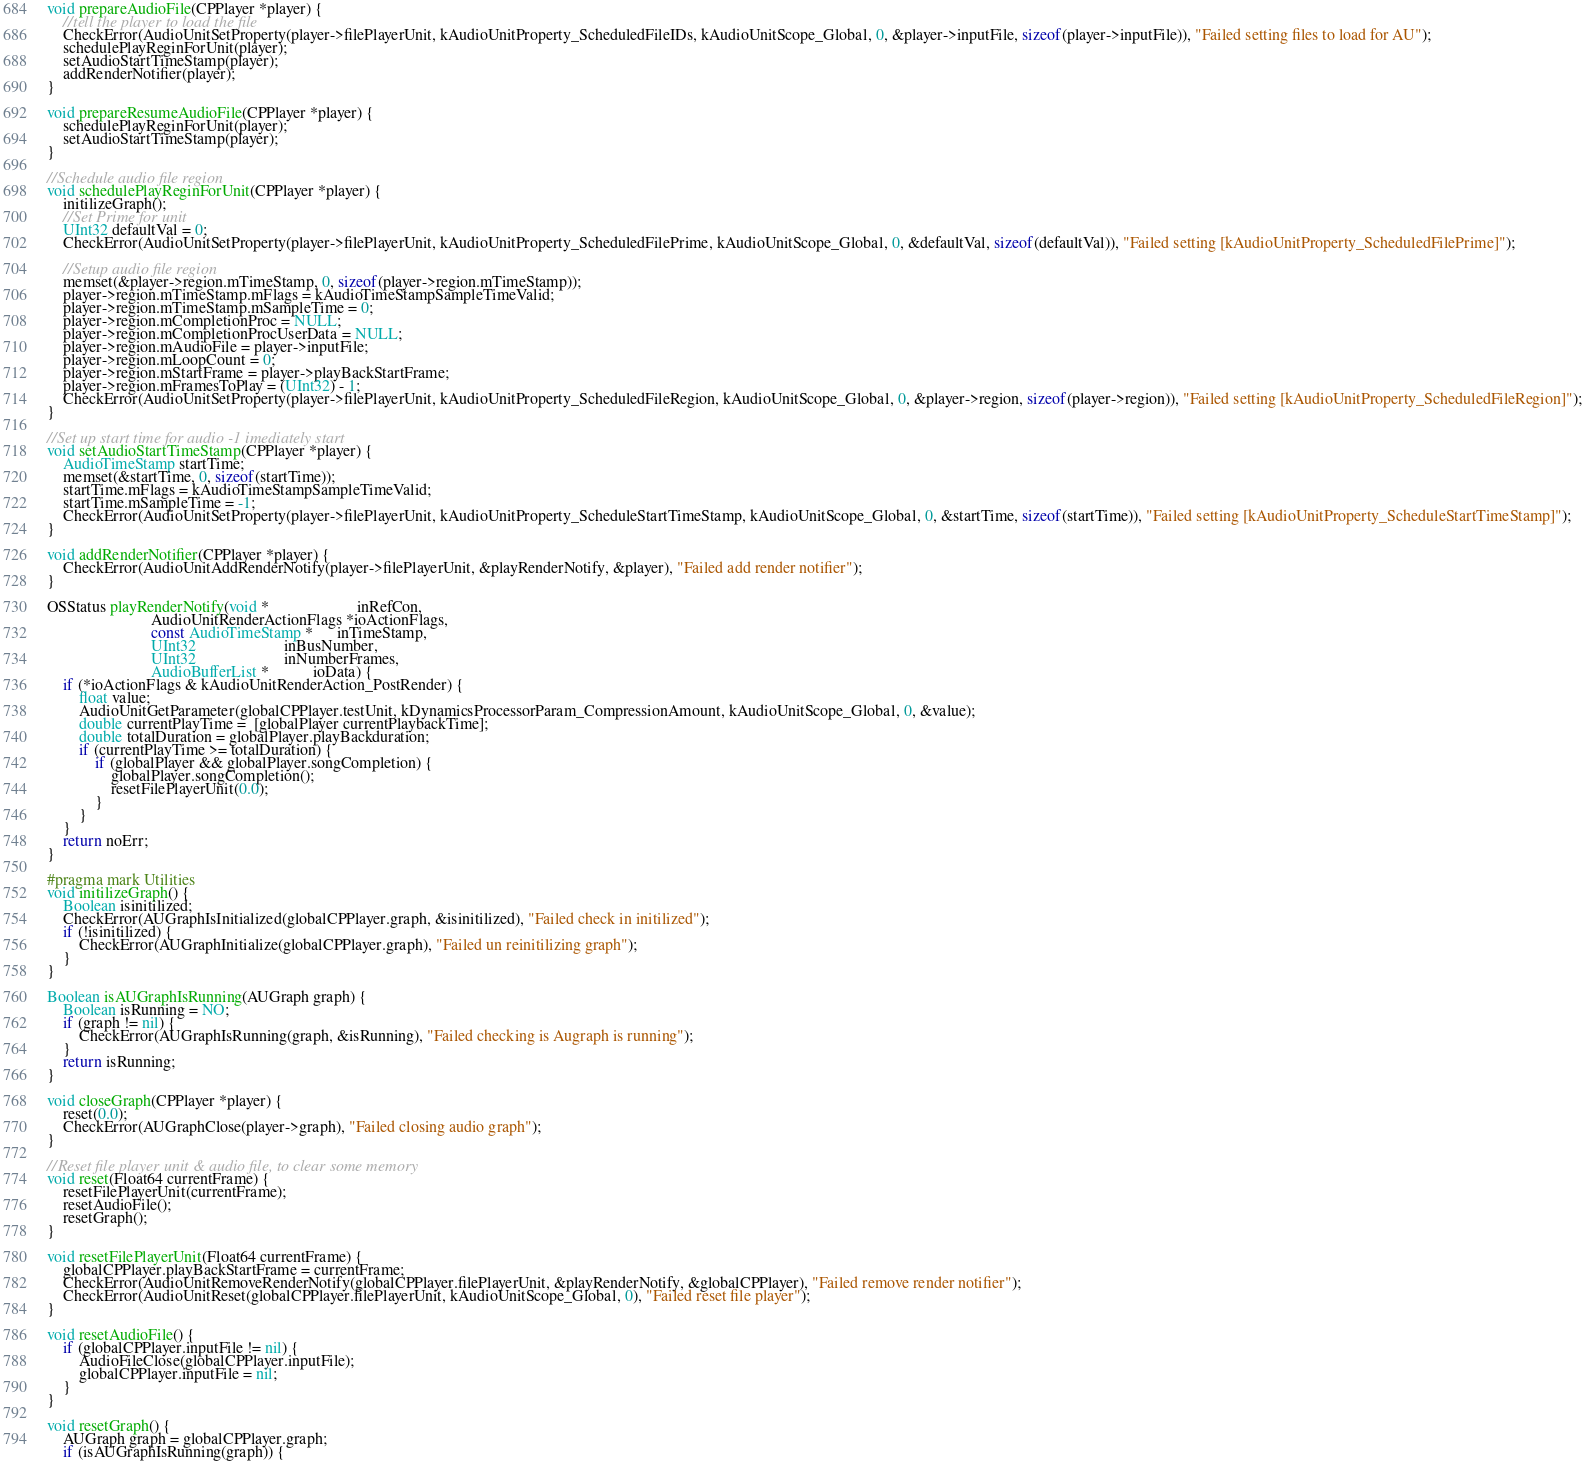<code> <loc_0><loc_0><loc_500><loc_500><_ObjectiveC_>void prepareAudioFile(CPPlayer *player) {
    //tell the player to load the file
    CheckError(AudioUnitSetProperty(player->filePlayerUnit, kAudioUnitProperty_ScheduledFileIDs, kAudioUnitScope_Global, 0, &player->inputFile, sizeof(player->inputFile)), "Failed setting files to load for AU");
    schedulePlayReginForUnit(player);
    setAudioStartTimeStamp(player);
    addRenderNotifier(player);
}

void prepareResumeAudioFile(CPPlayer *player) {
    schedulePlayReginForUnit(player);
    setAudioStartTimeStamp(player);
}

//Schedule audio file region
void schedulePlayReginForUnit(CPPlayer *player) {
    initilizeGraph();
    //Set Prime for unit
    UInt32 defaultVal = 0;
    CheckError(AudioUnitSetProperty(player->filePlayerUnit, kAudioUnitProperty_ScheduledFilePrime, kAudioUnitScope_Global, 0, &defaultVal, sizeof(defaultVal)), "Failed setting [kAudioUnitProperty_ScheduledFilePrime]");
    
    //Setup audio file region
    memset(&player->region.mTimeStamp, 0, sizeof(player->region.mTimeStamp));
    player->region.mTimeStamp.mFlags = kAudioTimeStampSampleTimeValid;
    player->region.mTimeStamp.mSampleTime = 0;
    player->region.mCompletionProc = NULL;
    player->region.mCompletionProcUserData = NULL;
    player->region.mAudioFile = player->inputFile;
    player->region.mLoopCount = 0;
    player->region.mStartFrame = player->playBackStartFrame;
    player->region.mFramesToPlay = (UInt32) - 1;
    CheckError(AudioUnitSetProperty(player->filePlayerUnit, kAudioUnitProperty_ScheduledFileRegion, kAudioUnitScope_Global, 0, &player->region, sizeof(player->region)), "Failed setting [kAudioUnitProperty_ScheduledFileRegion]");
}

//Set up start time for audio -1 imediately start
void setAudioStartTimeStamp(CPPlayer *player) {
    AudioTimeStamp startTime;
    memset(&startTime, 0, sizeof(startTime));
    startTime.mFlags = kAudioTimeStampSampleTimeValid;
    startTime.mSampleTime = -1;
    CheckError(AudioUnitSetProperty(player->filePlayerUnit, kAudioUnitProperty_ScheduleStartTimeStamp, kAudioUnitScope_Global, 0, &startTime, sizeof(startTime)), "Failed setting [kAudioUnitProperty_ScheduleStartTimeStamp]");
}

void addRenderNotifier(CPPlayer *player) {
    CheckError(AudioUnitAddRenderNotify(player->filePlayerUnit, &playRenderNotify, &player), "Failed add render notifier");
}

OSStatus playRenderNotify(void *                      inRefCon,
                          AudioUnitRenderActionFlags *ioActionFlags,
                          const AudioTimeStamp *      inTimeStamp,
                          UInt32                      inBusNumber,
                          UInt32                      inNumberFrames,
                          AudioBufferList *           ioData) {
    if (*ioActionFlags & kAudioUnitRenderAction_PostRender) {
        float value;
        AudioUnitGetParameter(globalCPPlayer.testUnit, kDynamicsProcessorParam_CompressionAmount, kAudioUnitScope_Global, 0, &value);
        double currentPlayTime =  [globalPlayer currentPlaybackTime];
        double totalDuration = globalPlayer.playBackduration;
        if (currentPlayTime >= totalDuration) {
            if (globalPlayer && globalPlayer.songCompletion) {
                globalPlayer.songCompletion();
                resetFilePlayerUnit(0.0);
            }
        }
    }
    return noErr;
}

#pragma mark Utilities
void initilizeGraph() {
    Boolean isinitilized;
    CheckError(AUGraphIsInitialized(globalCPPlayer.graph, &isinitilized), "Failed check in initilized");
    if (!isinitilized) {
        CheckError(AUGraphInitialize(globalCPPlayer.graph), "Failed un reinitilizing graph");
    }
}

Boolean isAUGraphIsRunning(AUGraph graph) {
    Boolean isRunning = NO;
    if (graph != nil) {
        CheckError(AUGraphIsRunning(graph, &isRunning), "Failed checking is Augraph is running");
    }
    return isRunning;
}

void closeGraph(CPPlayer *player) {
    reset(0.0);
    CheckError(AUGraphClose(player->graph), "Failed closing audio graph");
}

//Reset file player unit & audio file, to clear some memory
void reset(Float64 currentFrame) {
    resetFilePlayerUnit(currentFrame);
    resetAudioFile();
    resetGraph();
}

void resetFilePlayerUnit(Float64 currentFrame) {
    globalCPPlayer.playBackStartFrame = currentFrame;
    CheckError(AudioUnitRemoveRenderNotify(globalCPPlayer.filePlayerUnit, &playRenderNotify, &globalCPPlayer), "Failed remove render notifier");
    CheckError(AudioUnitReset(globalCPPlayer.filePlayerUnit, kAudioUnitScope_Global, 0), "Failed reset file player");
}

void resetAudioFile() {
    if (globalCPPlayer.inputFile != nil) {
        AudioFileClose(globalCPPlayer.inputFile);
        globalCPPlayer.inputFile = nil;
    }
}

void resetGraph() {
    AUGraph graph = globalCPPlayer.graph;
    if (isAUGraphIsRunning(graph)) {</code> 